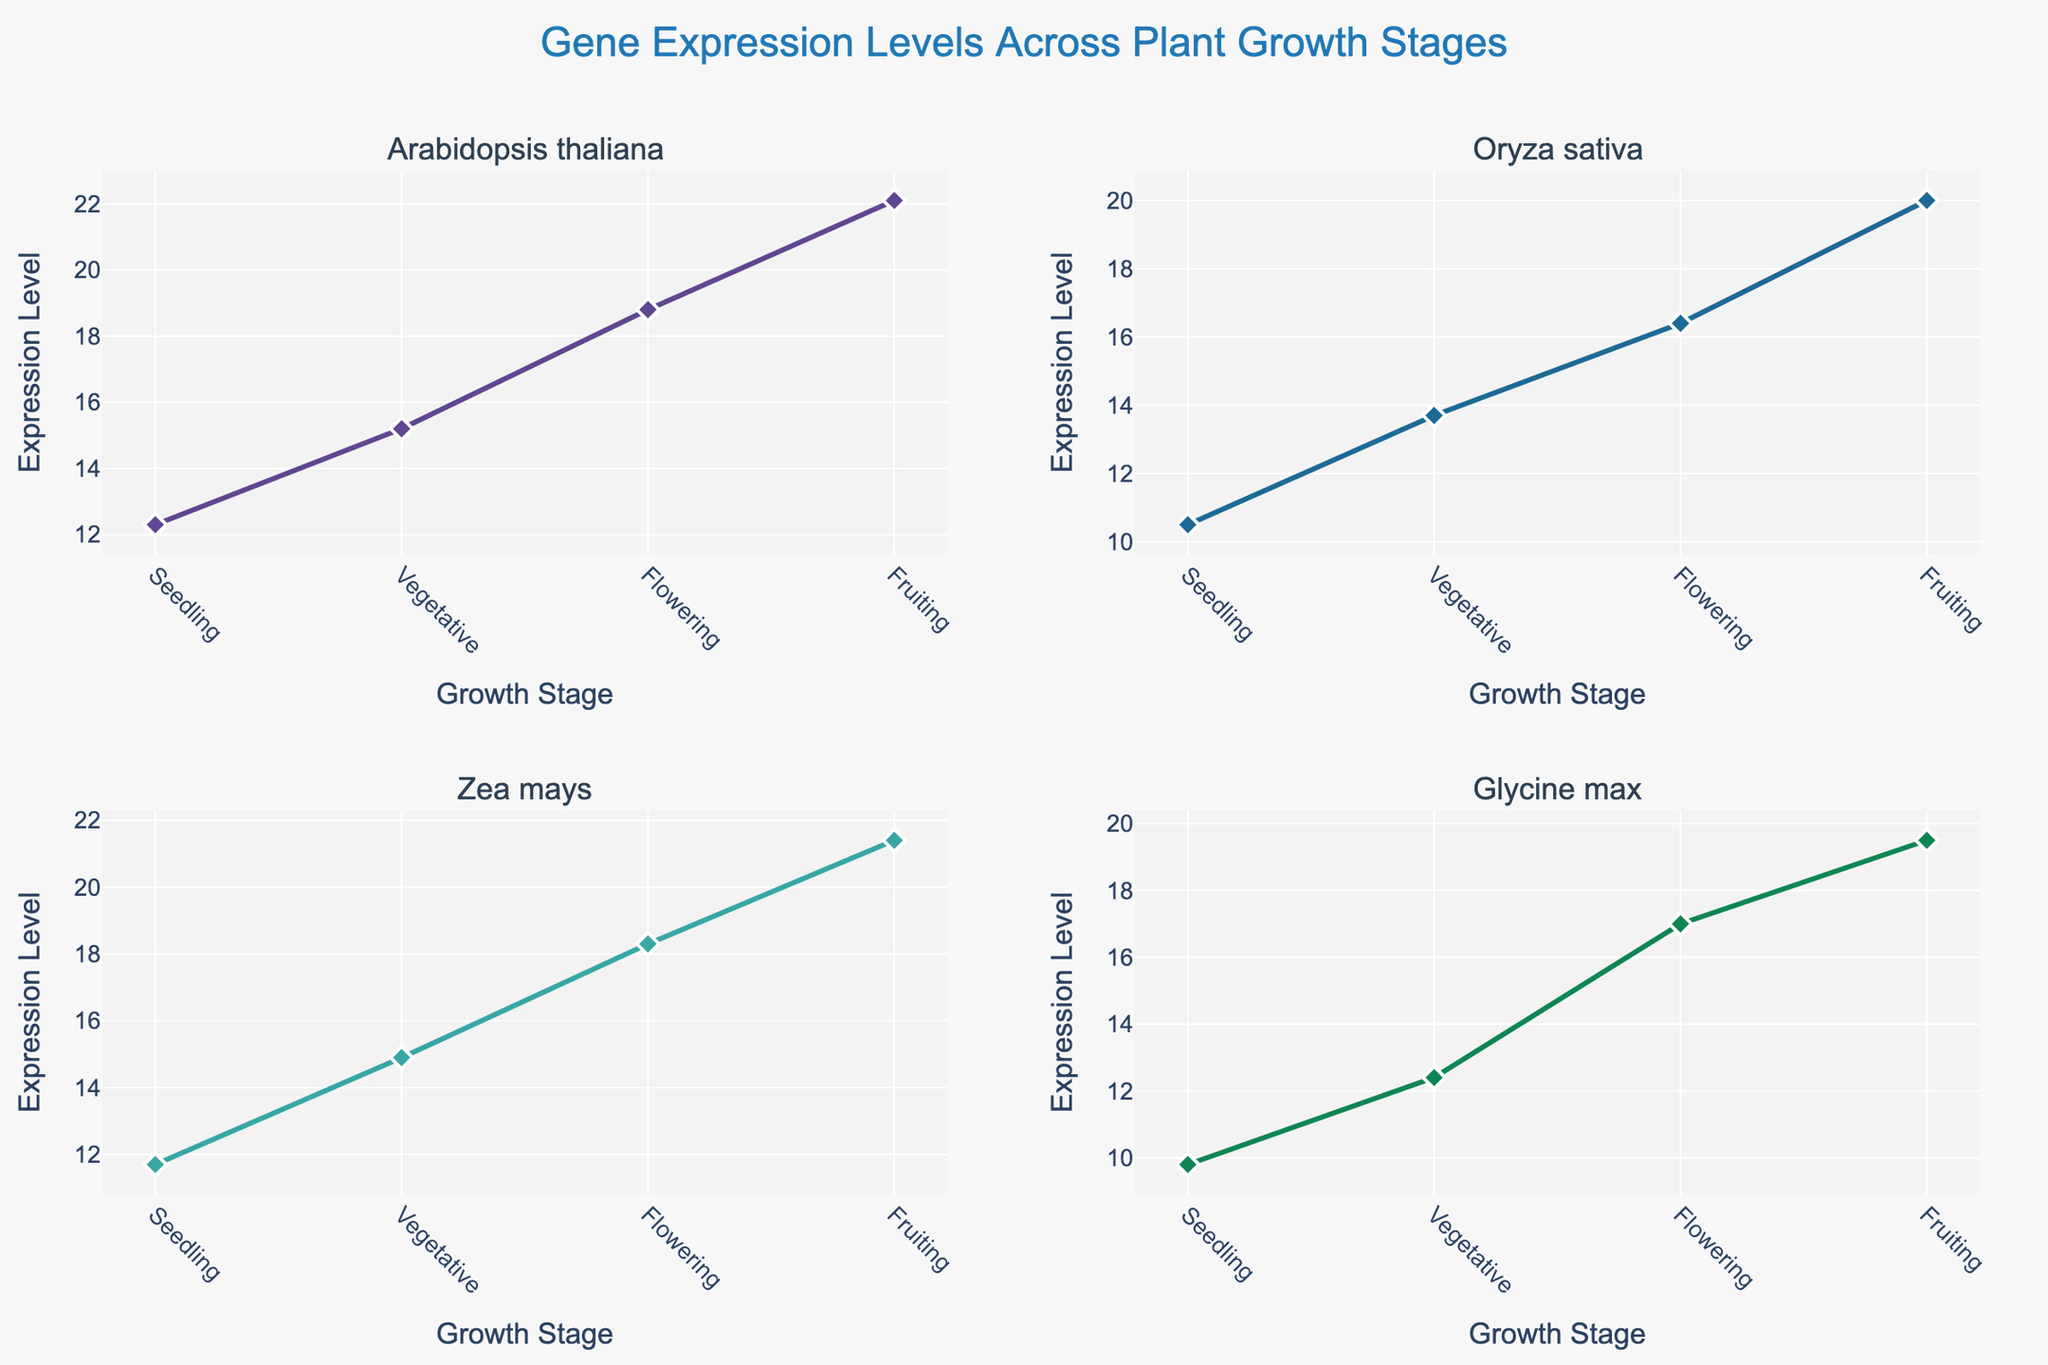What's the title of the figure? The title is displayed at the top center of the figure in a larger font size. It reads "Gene Expression Levels Across Plant Growth Stages"
Answer: Gene Expression Levels Across Plant Growth Stages How many unique plants are included in the figure? There are subplots for each unique plant with titles indicating their names. A total of 4 subplots represent 4 different plants.
Answer: 4 Which plant has the highest expression level at the Fruiting stage? By observing the y-axis values and the Fruiting stage data points for each subplot, Arabidopsis thaliana has the highest expression level at the Fruiting stage, with an expression level of 22.1
Answer: Arabidopsis thaliana What is the general trend of gene expression levels across development stages for Glycine max? The plot line for Glycine max shows data points increasing from Seedling to Fruiting. This indicates an increasing trend in expression levels across growth stages.
Answer: Increasing How many data points are there for each plant? Each subplot shows data points for four growth stages: Seedling, Vegetative, Flowering, and Fruiting, resulting in 4 data points per plant.
Answer: 4 Compare the expression levels of PR1 gene in Arabidopsis thaliana at Seedling and Flowering stages. Look at the subplot for Arabidopsis thaliana and note the expression levels at Seedling (12.3) and Flowering (18.8) stages. Calculate the difference: 18.8 - 12.3
Answer: 6.5 Is there any plant where the expression level decreases at any growth stage? Check each subplot to see if any points decrease as the stages progress. There are no decreases in any of the growth stages for the shown plant genes.
Answer: No What is the average expression level of NPR1 gene in Oryza sativa across all growth stages? Sum the expression levels across all growth stages and divide by the number of stages: (10.5 + 13.7 + 16.4 + 20.0) / 4
Answer: 15.15 Which gene has the most significant increase in expression level from Seedling to Fruiting? Calculate the difference between expression levels at Seedling and Fruiting stages for each subplot: PR1 (22.1-12.3=9.8), NPR1 (20.0-10.5=9.5), PIN1 (21.4-11.7=9.7), JAZ (19.5-9.8=9.7)
Answer: PR1 (Arabidopsis thaliana) Which plant shows the most consistent increase in gene expression level across all stages? Look for a steady and nearly equal incremental increase across all growth stages. Arabidopsis thaliana shows consistent increments (Seedling: 12.3, Vegetative: 15.2, Flowering: 18.8, Fruiting: 22.1)
Answer: Arabidopsis thaliana 